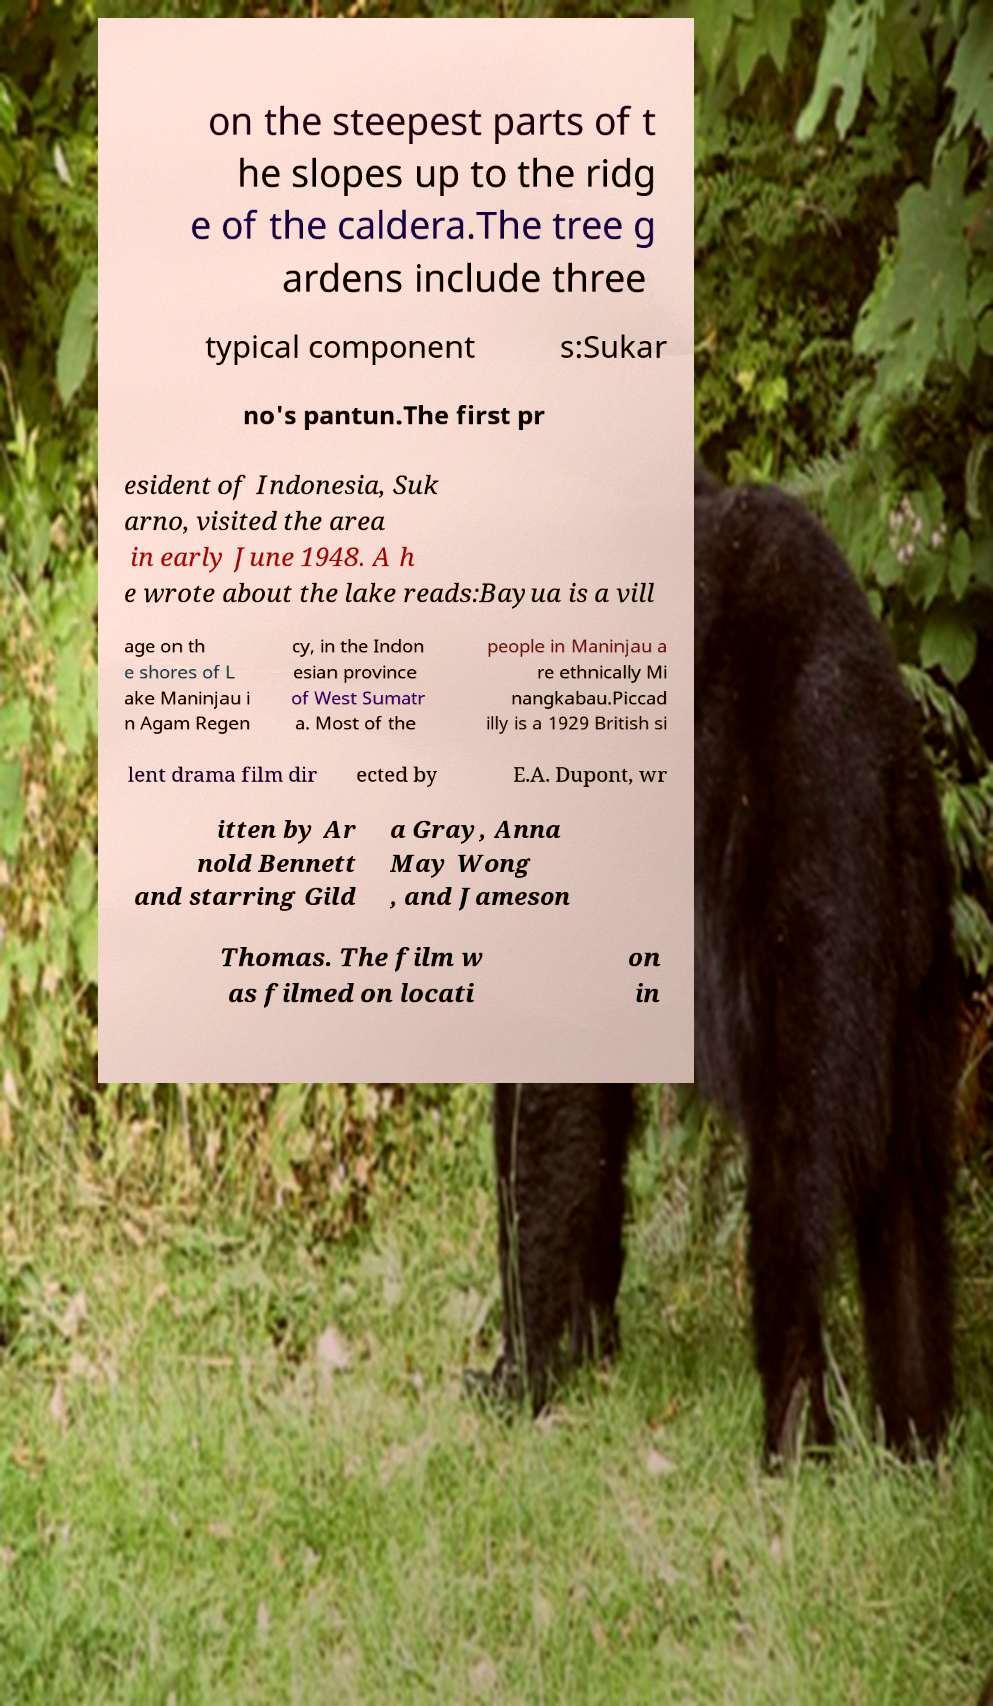There's text embedded in this image that I need extracted. Can you transcribe it verbatim? on the steepest parts of t he slopes up to the ridg e of the caldera.The tree g ardens include three typical component s:Sukar no's pantun.The first pr esident of Indonesia, Suk arno, visited the area in early June 1948. A h e wrote about the lake reads:Bayua is a vill age on th e shores of L ake Maninjau i n Agam Regen cy, in the Indon esian province of West Sumatr a. Most of the people in Maninjau a re ethnically Mi nangkabau.Piccad illy is a 1929 British si lent drama film dir ected by E.A. Dupont, wr itten by Ar nold Bennett and starring Gild a Gray, Anna May Wong , and Jameson Thomas. The film w as filmed on locati on in 